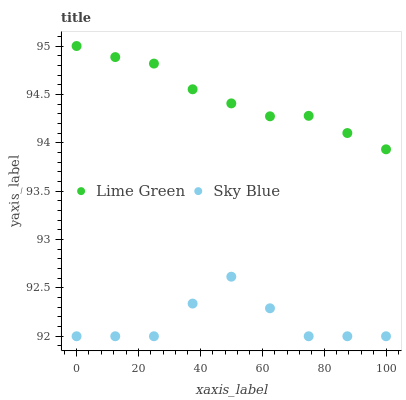Does Sky Blue have the minimum area under the curve?
Answer yes or no. Yes. Does Lime Green have the maximum area under the curve?
Answer yes or no. Yes. Does Lime Green have the minimum area under the curve?
Answer yes or no. No. Is Lime Green the smoothest?
Answer yes or no. Yes. Is Sky Blue the roughest?
Answer yes or no. Yes. Is Lime Green the roughest?
Answer yes or no. No. Does Sky Blue have the lowest value?
Answer yes or no. Yes. Does Lime Green have the lowest value?
Answer yes or no. No. Does Lime Green have the highest value?
Answer yes or no. Yes. Is Sky Blue less than Lime Green?
Answer yes or no. Yes. Is Lime Green greater than Sky Blue?
Answer yes or no. Yes. Does Sky Blue intersect Lime Green?
Answer yes or no. No. 